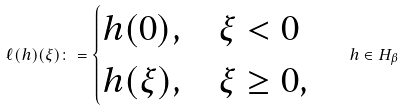<formula> <loc_0><loc_0><loc_500><loc_500>\ell ( h ) ( \xi ) \colon = \begin{cases} h ( 0 ) , & \xi < 0 \\ h ( \xi ) , & \xi \geq 0 , \end{cases} \quad h \in H _ { \beta }</formula> 